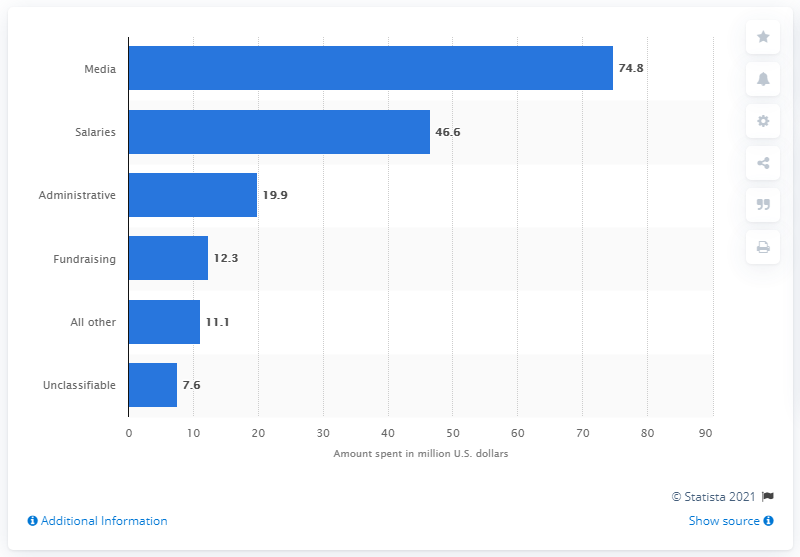Point out several critical features in this image. As of August 2016, Hillary Clinton's campaign had spent approximately $74.8 million on media expenses. 